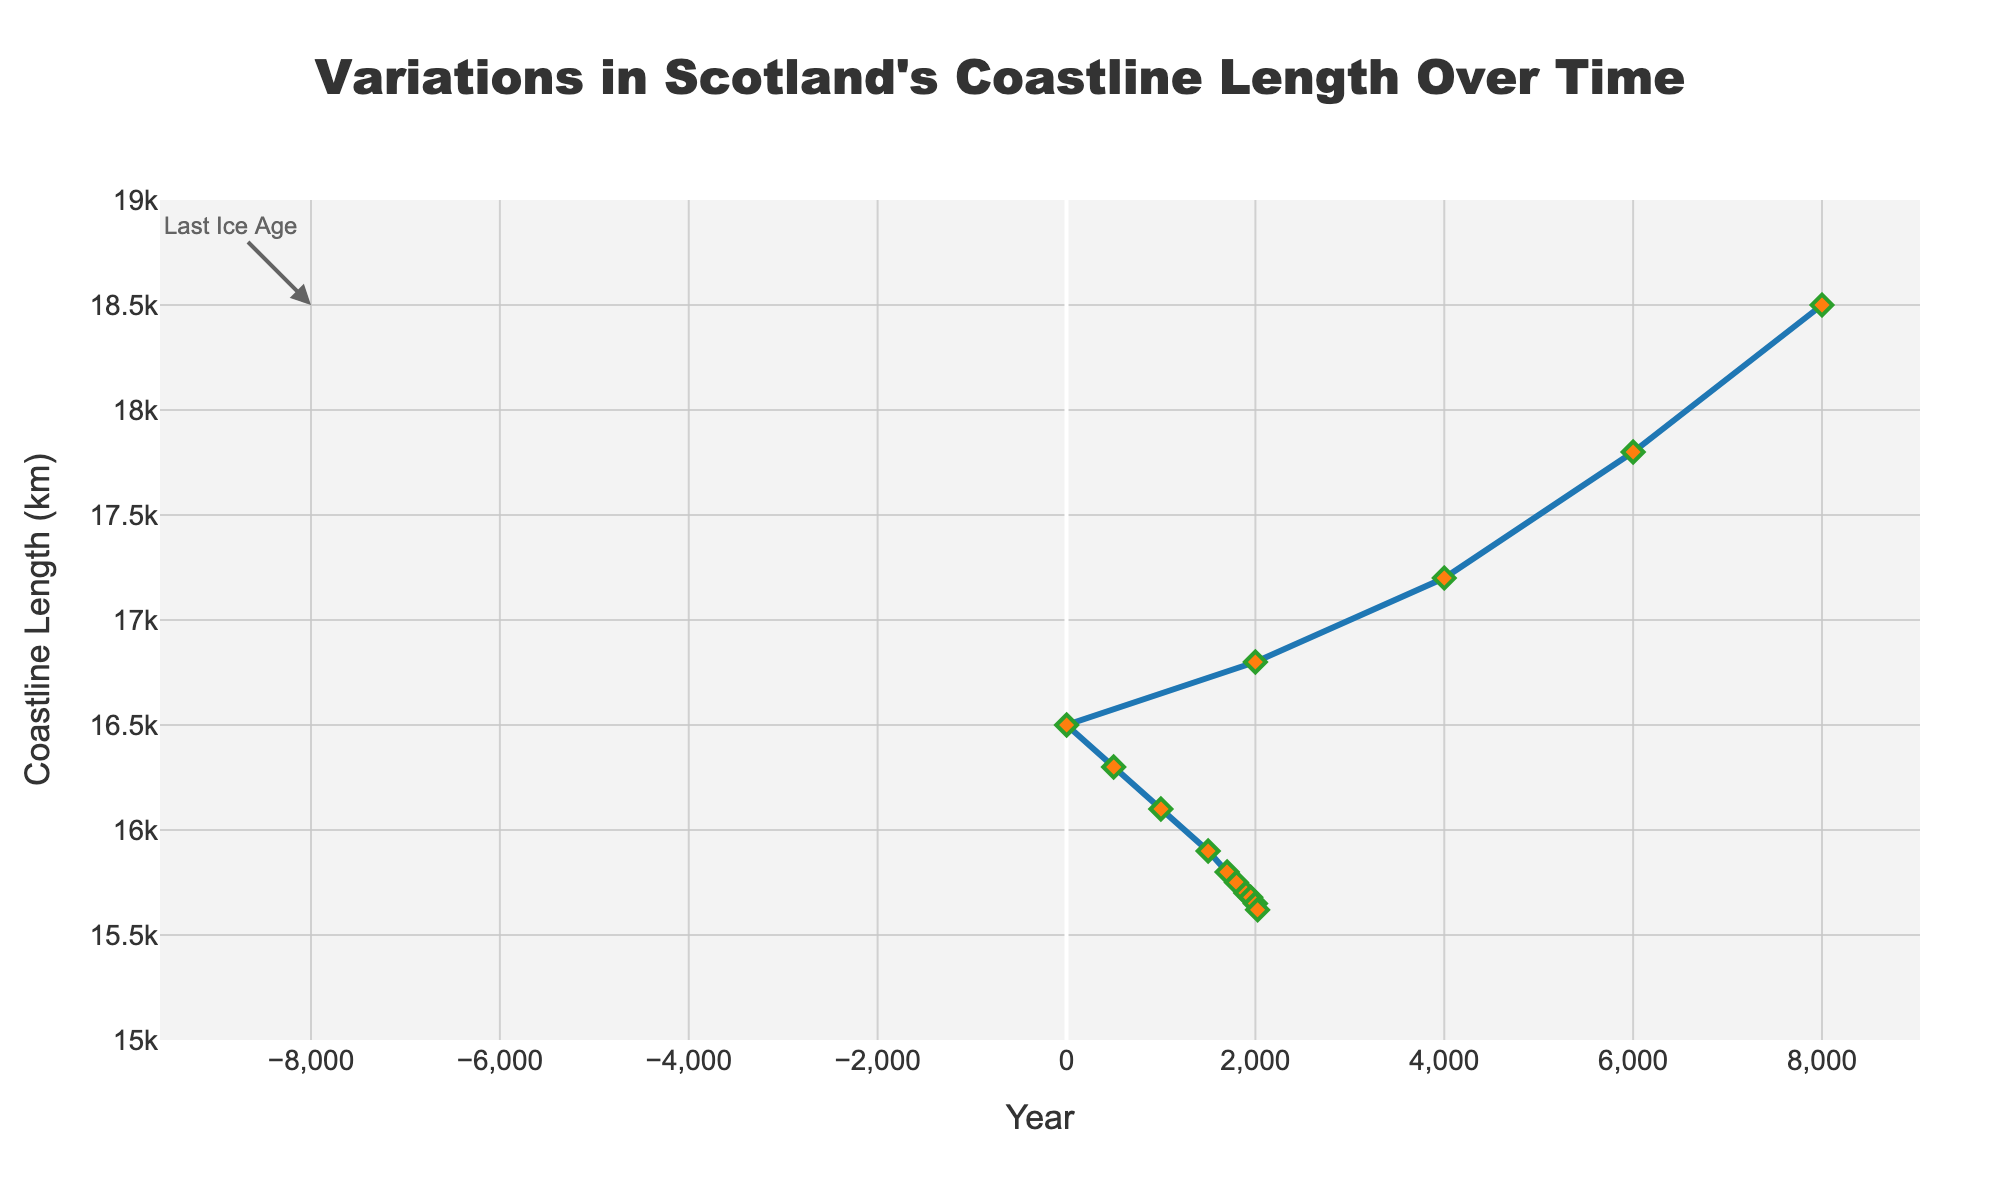What is the length of the coastline of Scotland in 8000 BC? The chart shows a data point labeled "Last Ice Age" at the beginning of the timeline, with the coastline length clearly marked. Looking at this data point, the length is approximately 18500 km.
Answer: 18500 km How much did the coastline length decrease from 8000 BC to 6000 BC? To find the decrease, subtract the coastline length in 6000 BC from the length in 8000 BC: 18500 km - 17800 km = 700 km.
Answer: 700 km Is the rate of decrease in coastline length higher before 1 AD or after 1 AD? Calculate the rate before 1 AD: (18500 km - 16500 km) / (8000 - 1) years. Calculate the rate after 1 AD: (16500 km - 15620 km) / (2023 - 1) years. Compare the two rates to determine which is higher.
Answer: Before 1 AD Between which years did the coastline length decrease the most? By observing the steepness of the line, the steepest decline is between 2000 BC to 1 AD. This segment shows the most significant drop in the coastline length.
Answer: 2000 BC to 1 AD What is the average coastline length between 1900 AD and 2023 AD? Sum the coastline lengths for the years 1900 AD, 1950 AD, 2000 AD, and 2023 AD and then divide by 4: (15700 + 15680 + 15650 + 15620) / 4 = 15662.5 km
Answer: 15662.5 km Has the rate of coastline length reduction been relatively constant over the periods displayed? By examining the slope of the line on the chart, one can observe if it remains consistent or varies. Some periods have steeper drops, indicating faster reduction, whereas others show slower decline, indicating a varying rate.
Answer: No Does the coastline length reduction show any significant change in the past century (1900 AD - 2023 AD)? Observe the portion of the graph from 1900 AD to 2023 AD. The decline seems linear and less steep. Comparing it with earlier periods shows a slower rate of reduction.
Answer: Less significant What is the percentage decrease in coastline length from 8000 BC to 2023 AD? Calculate the percentage by the formula: [(Initial length - Final length) / Initial length] × 100. Using the data: [(18500 - 15620) / 18500] × 100 ≈ 15.59%.
Answer: 15.59% Which period (2000 BC to 1 AD or 1000 AD to 1500 AD) experienced a larger decrease in coastline length? Calculate the decrease in both periods: For 2000 BC to 1 AD: 16800 km - 16500 km = 300 km. For 1000 AD to 1500 AD: 16100 km - 15900 km = 200 km. Thus, 2000 BC to 1 AD experienced a larger decrease.
Answer: 2000 BC to 1 AD What is the visual pattern observed in the coastline length change from 2000 AD to 2023 AD? Observe the graph segment from 2000 AD to 2023 AD. The line in this range shows a relatively small and smooth decrease in coastline length, indicating a slow and steady reduction.
Answer: Slow and steady reduction 